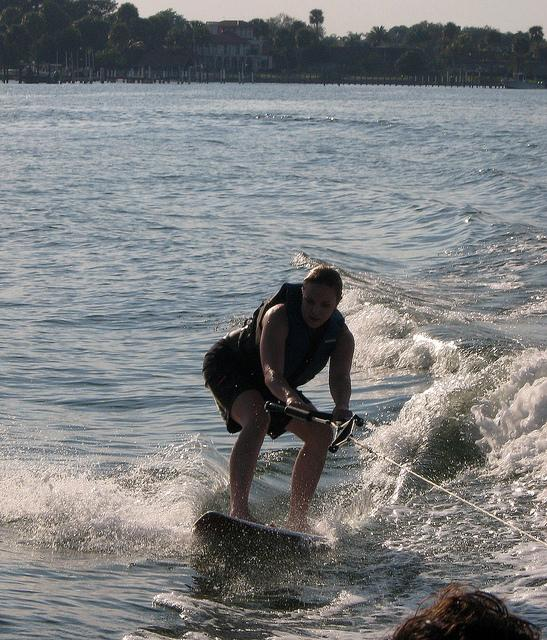What form of exercise is this?

Choices:
A) jet skiing
B) surfboarding
C) water skiing
D) water boarding water skiing 